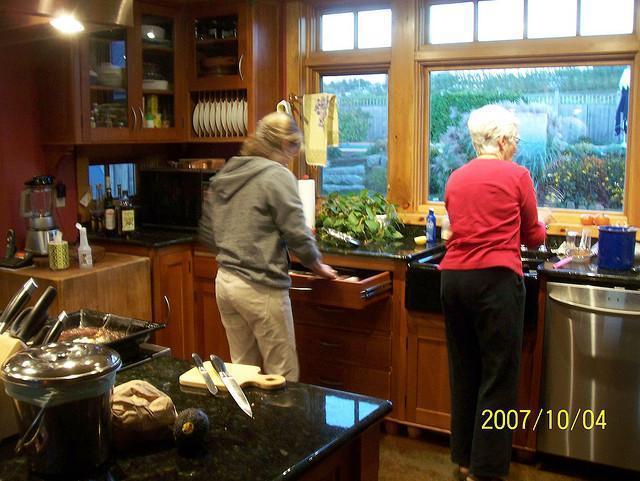How many women are in the kitchen?
Give a very brief answer. 2. How many knives are on the cutting board?
Give a very brief answer. 2. How many people are visible?
Give a very brief answer. 2. How many ovens are visible?
Give a very brief answer. 2. How many microwaves are visible?
Give a very brief answer. 1. How many oranges that are not in the bowl?
Give a very brief answer. 0. 